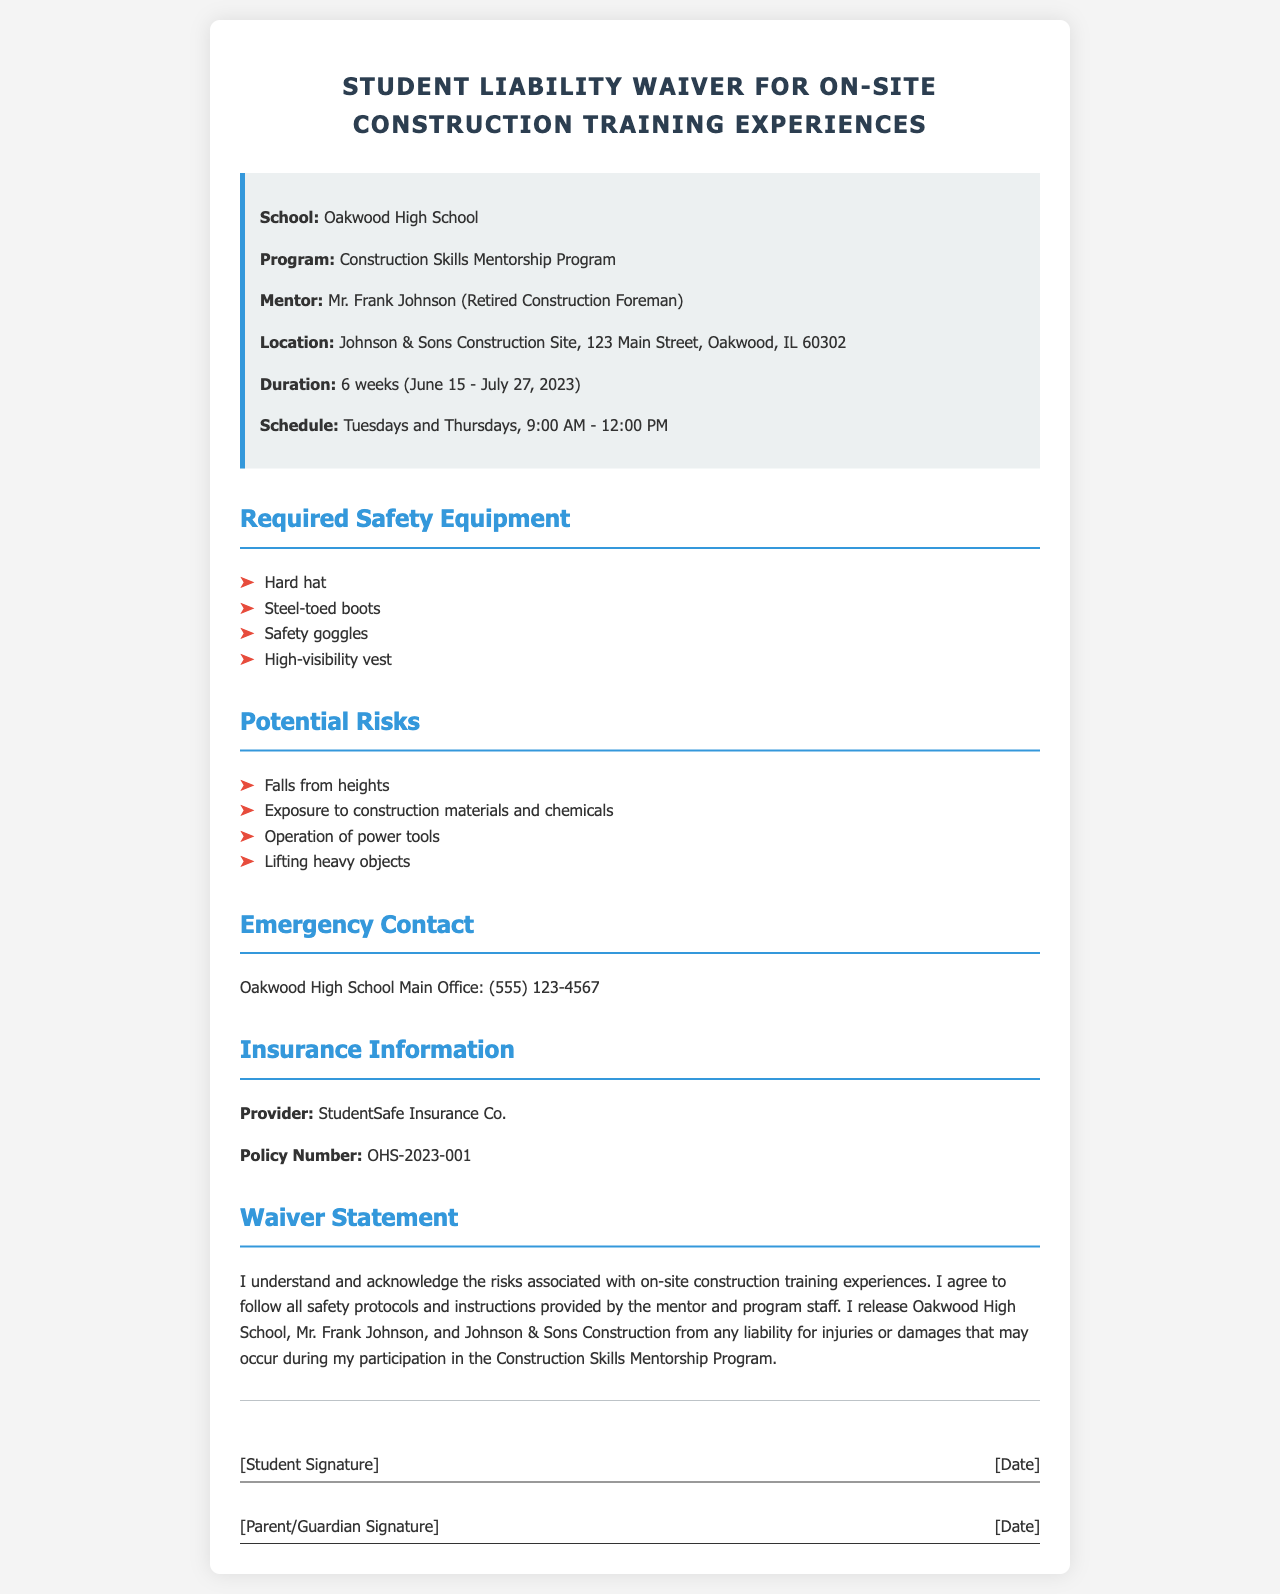what is the name of the school? The school is mentioned in the document as Oakwood High School.
Answer: Oakwood High School who is the mentor of the program? The document states that the mentor is Mr. Frank Johnson, who is a retired construction foreman.
Answer: Mr. Frank Johnson what is the duration of the training program? The duration is specified in the document as 6 weeks, from June 15 to July 27, 2023.
Answer: 6 weeks what is the first required safety equipment listed? The document lists hard hat as the first required safety equipment for the training program.
Answer: Hard hat what is the privacy status of the waiver statement? The waiver statement indicates that participants release Oakwood High School, Mr. Frank Johnson, and Johnson & Sons Construction from liability.
Answer: Liability release how many sessions are scheduled per week? The document states that sessions are scheduled for Tuesdays and Thursdays, which counts as two sessions per week.
Answer: Two sessions what type of insurance provider is mentioned? The insurance provider referenced in the document is StudentSafe Insurance Co.
Answer: StudentSafe Insurance Co what is the contact number for the emergency contact? The emergency contact number for Oakwood High School is provided as (555) 123-4567.
Answer: (555) 123-4567 which location hosts the construction training? The document specifies that the training takes place at Johnson & Sons Construction Site, located at 123 Main Street, Oakwood, IL 60302.
Answer: Johnson & Sons Construction Site, 123 Main Street, Oakwood, IL 60302 